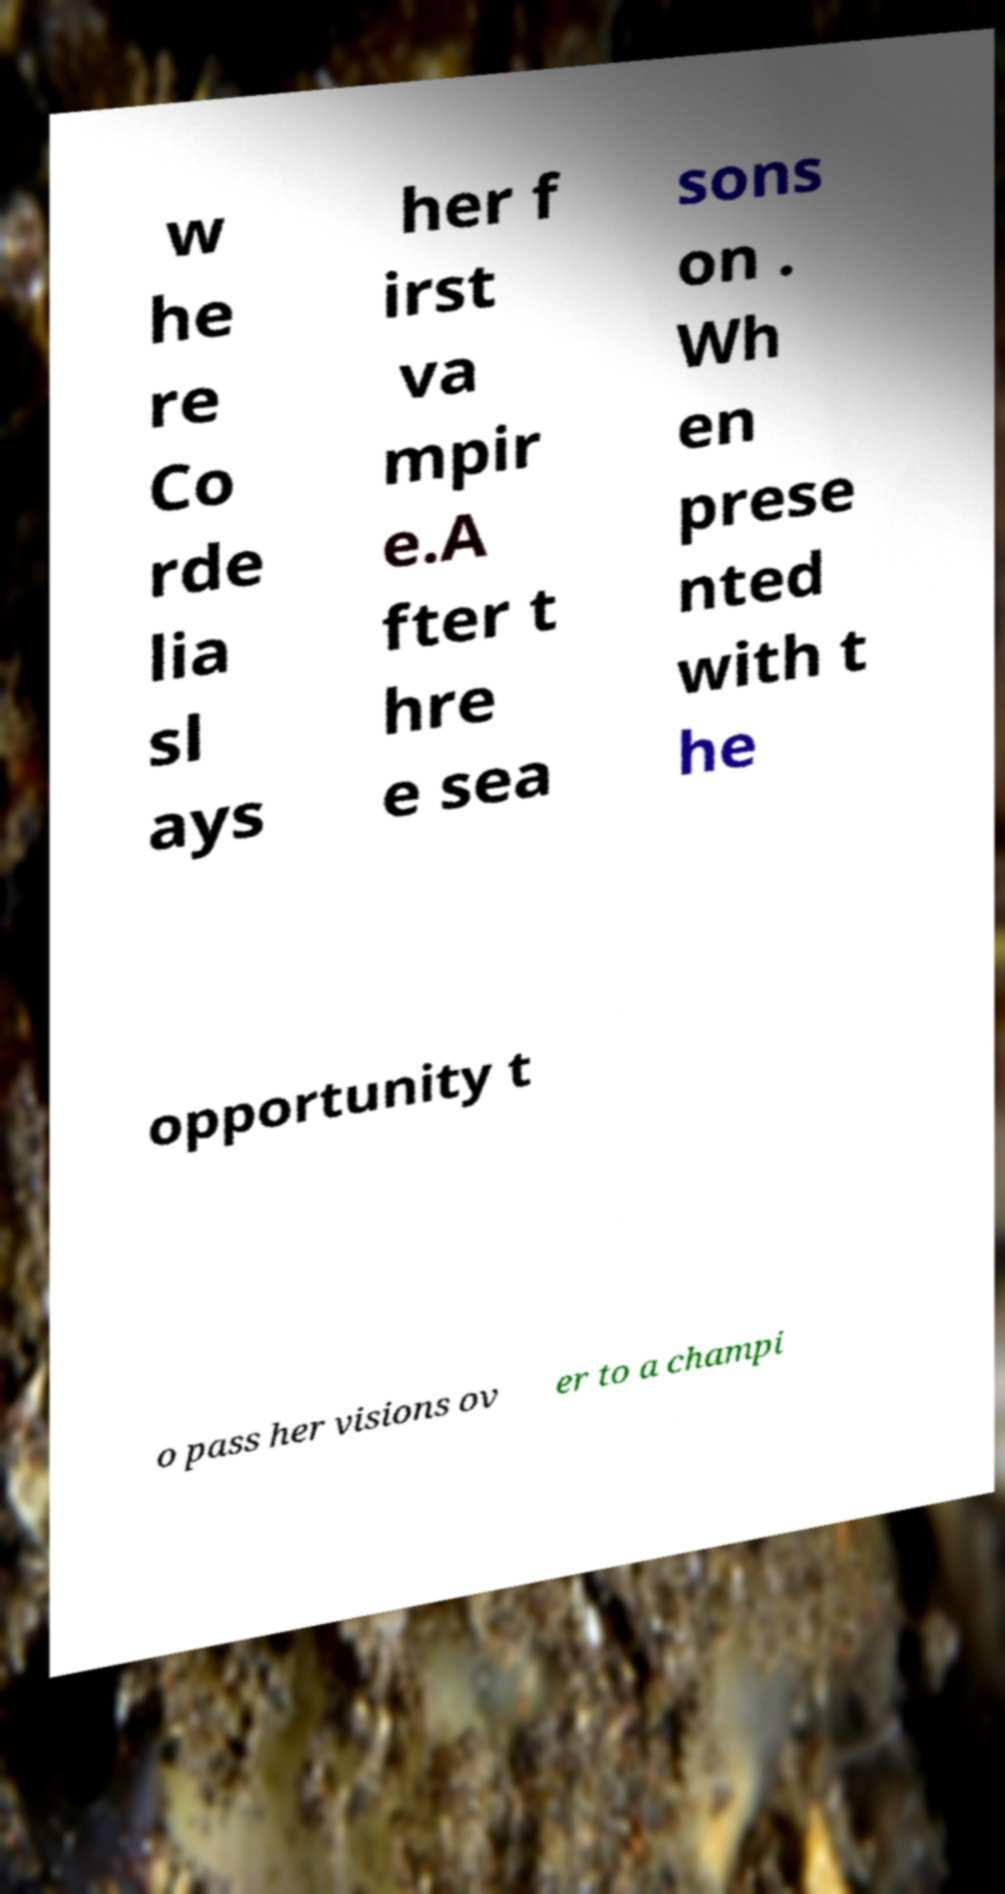What messages or text are displayed in this image? I need them in a readable, typed format. w he re Co rde lia sl ays her f irst va mpir e.A fter t hre e sea sons on . Wh en prese nted with t he opportunity t o pass her visions ov er to a champi 